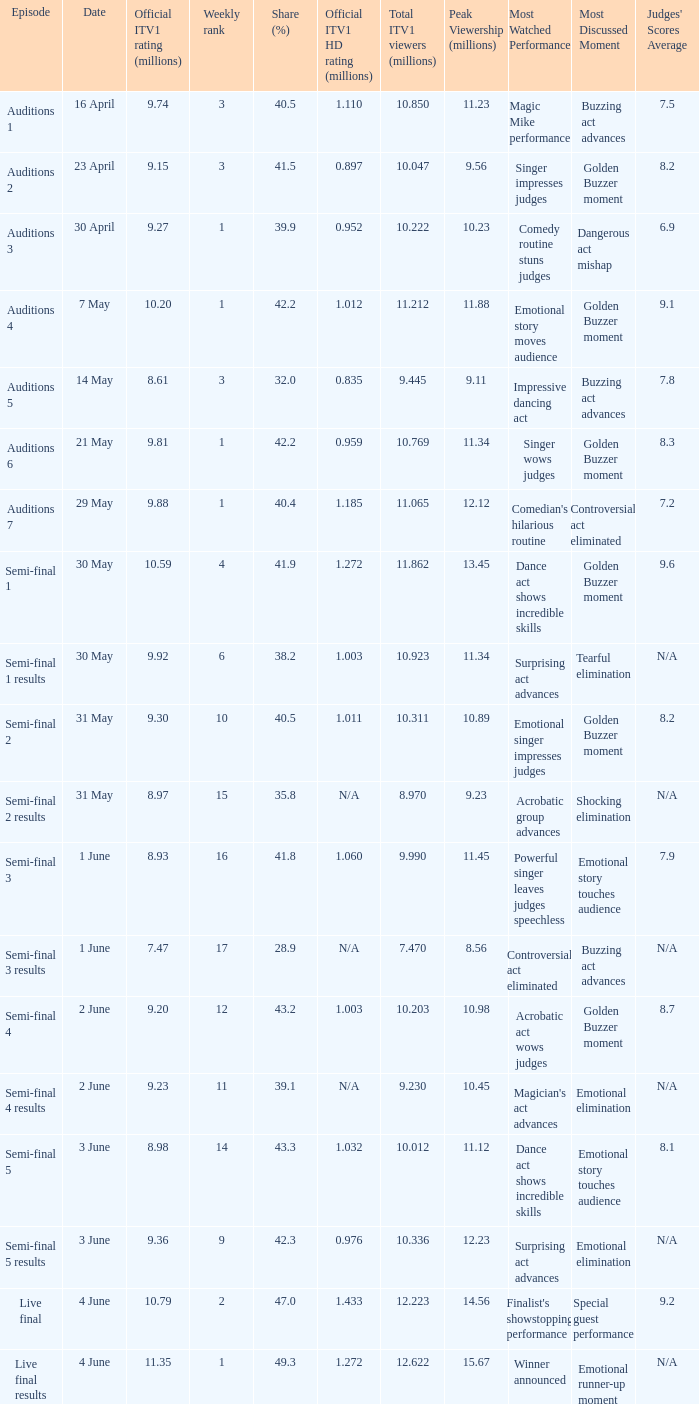What was the official ITV1 HD rating in millions for the episode that had an official ITV1 rating of 8.98 million? 1.032. 